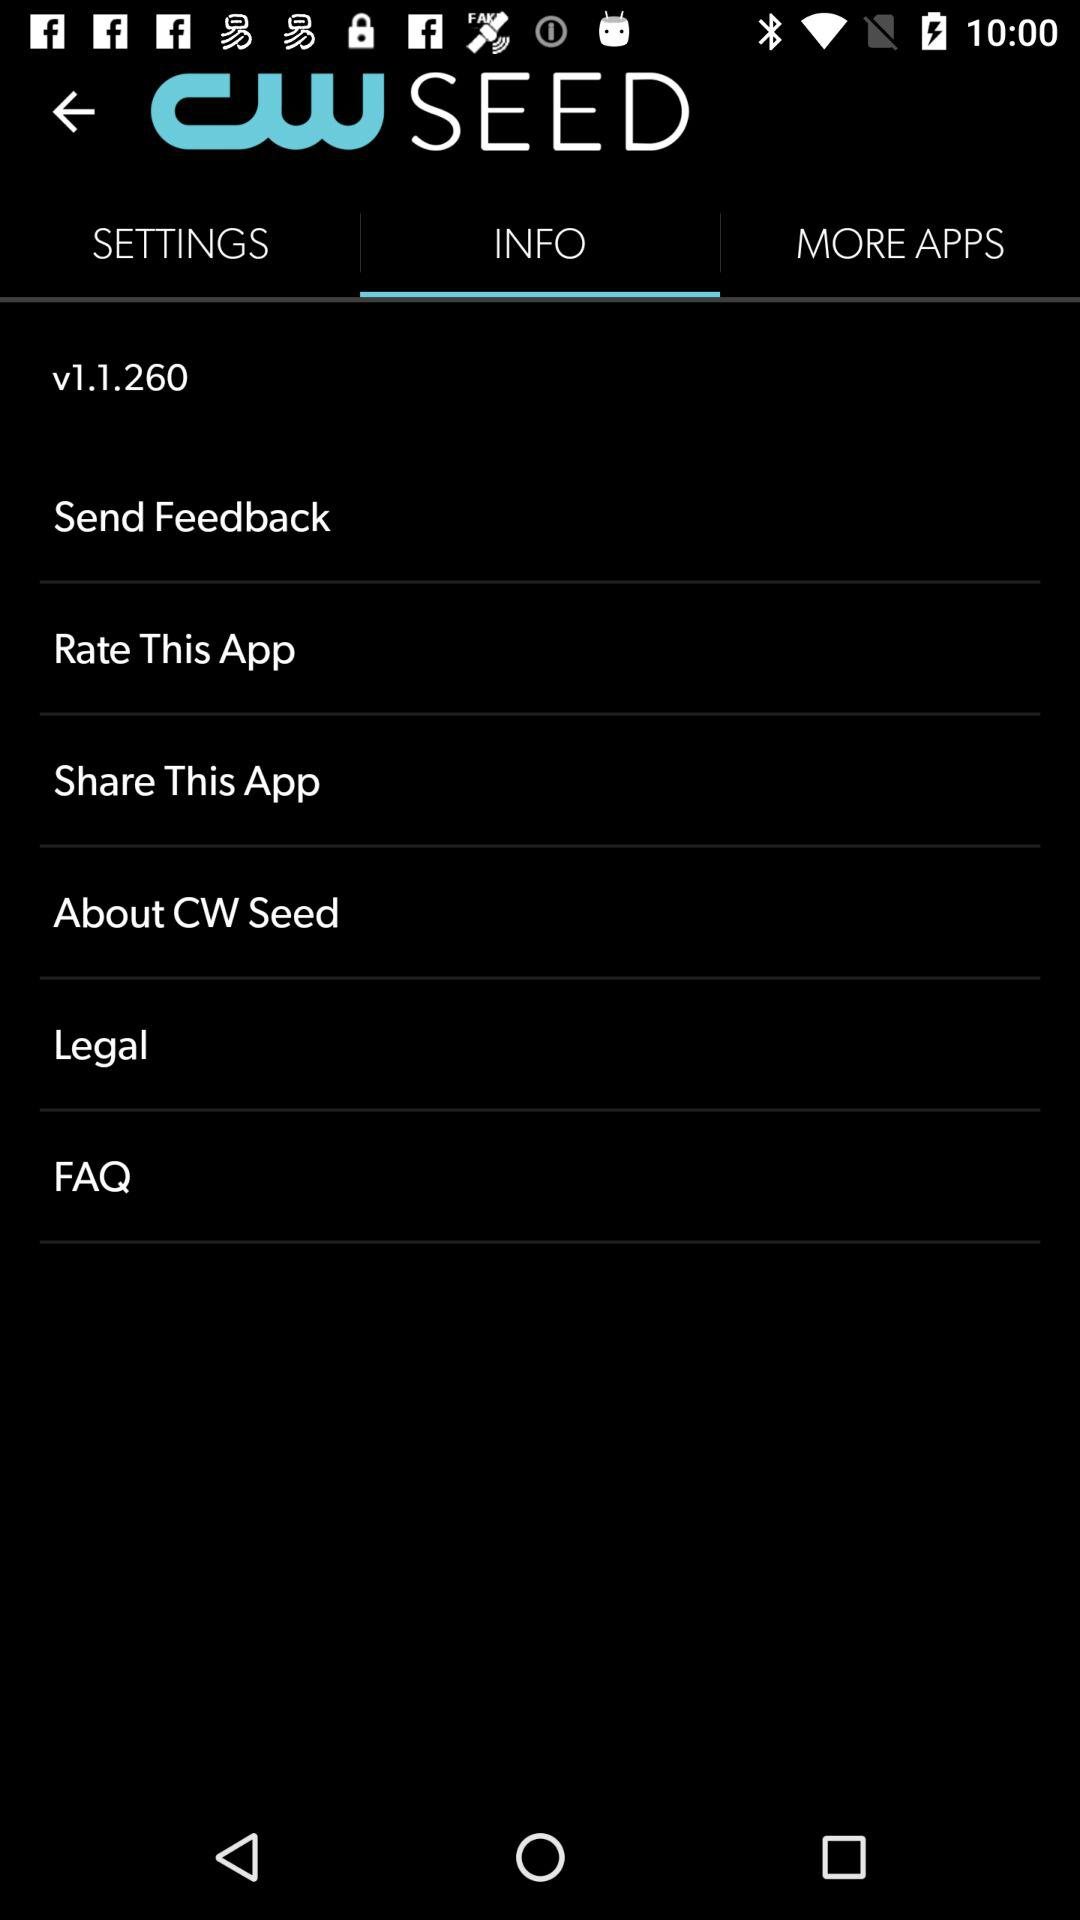What is the version of the application being used? The version of the application is v1.1.260. 